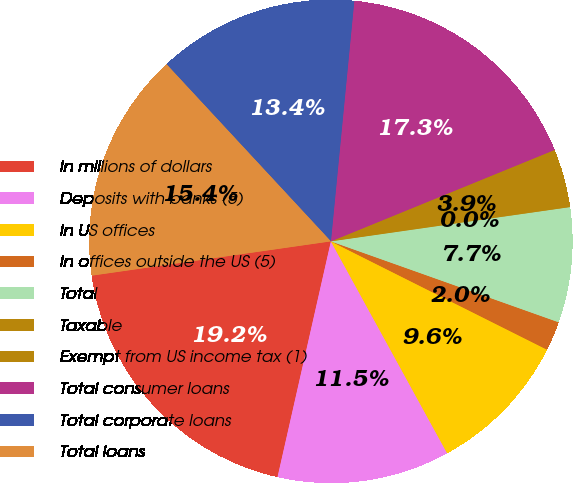Convert chart to OTSL. <chart><loc_0><loc_0><loc_500><loc_500><pie_chart><fcel>In millions of dollars<fcel>Deposits with banks (5)<fcel>In US offices<fcel>In offices outside the US (5)<fcel>Total<fcel>Taxable<fcel>Exempt from US income tax (1)<fcel>Total consumer loans<fcel>Total corporate loans<fcel>Total loans<nl><fcel>19.19%<fcel>11.53%<fcel>9.62%<fcel>1.96%<fcel>7.7%<fcel>0.04%<fcel>3.87%<fcel>17.28%<fcel>13.45%<fcel>15.36%<nl></chart> 